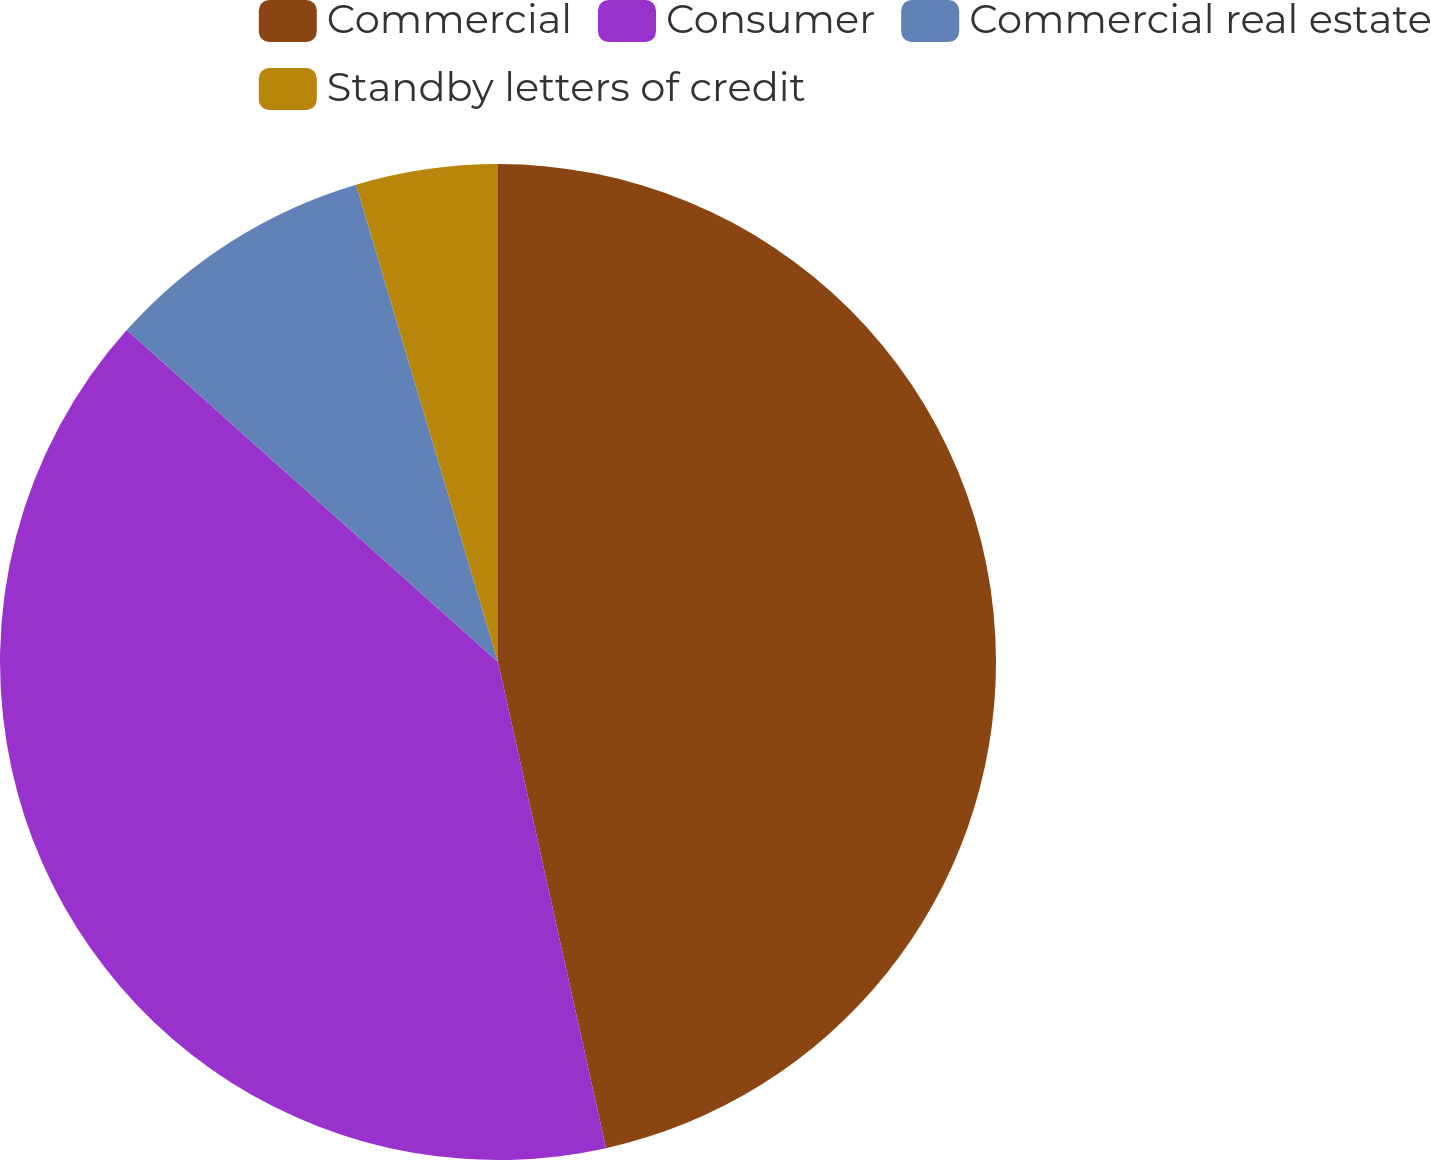Convert chart to OTSL. <chart><loc_0><loc_0><loc_500><loc_500><pie_chart><fcel>Commercial<fcel>Consumer<fcel>Commercial real estate<fcel>Standby letters of credit<nl><fcel>46.52%<fcel>40.09%<fcel>8.79%<fcel>4.6%<nl></chart> 